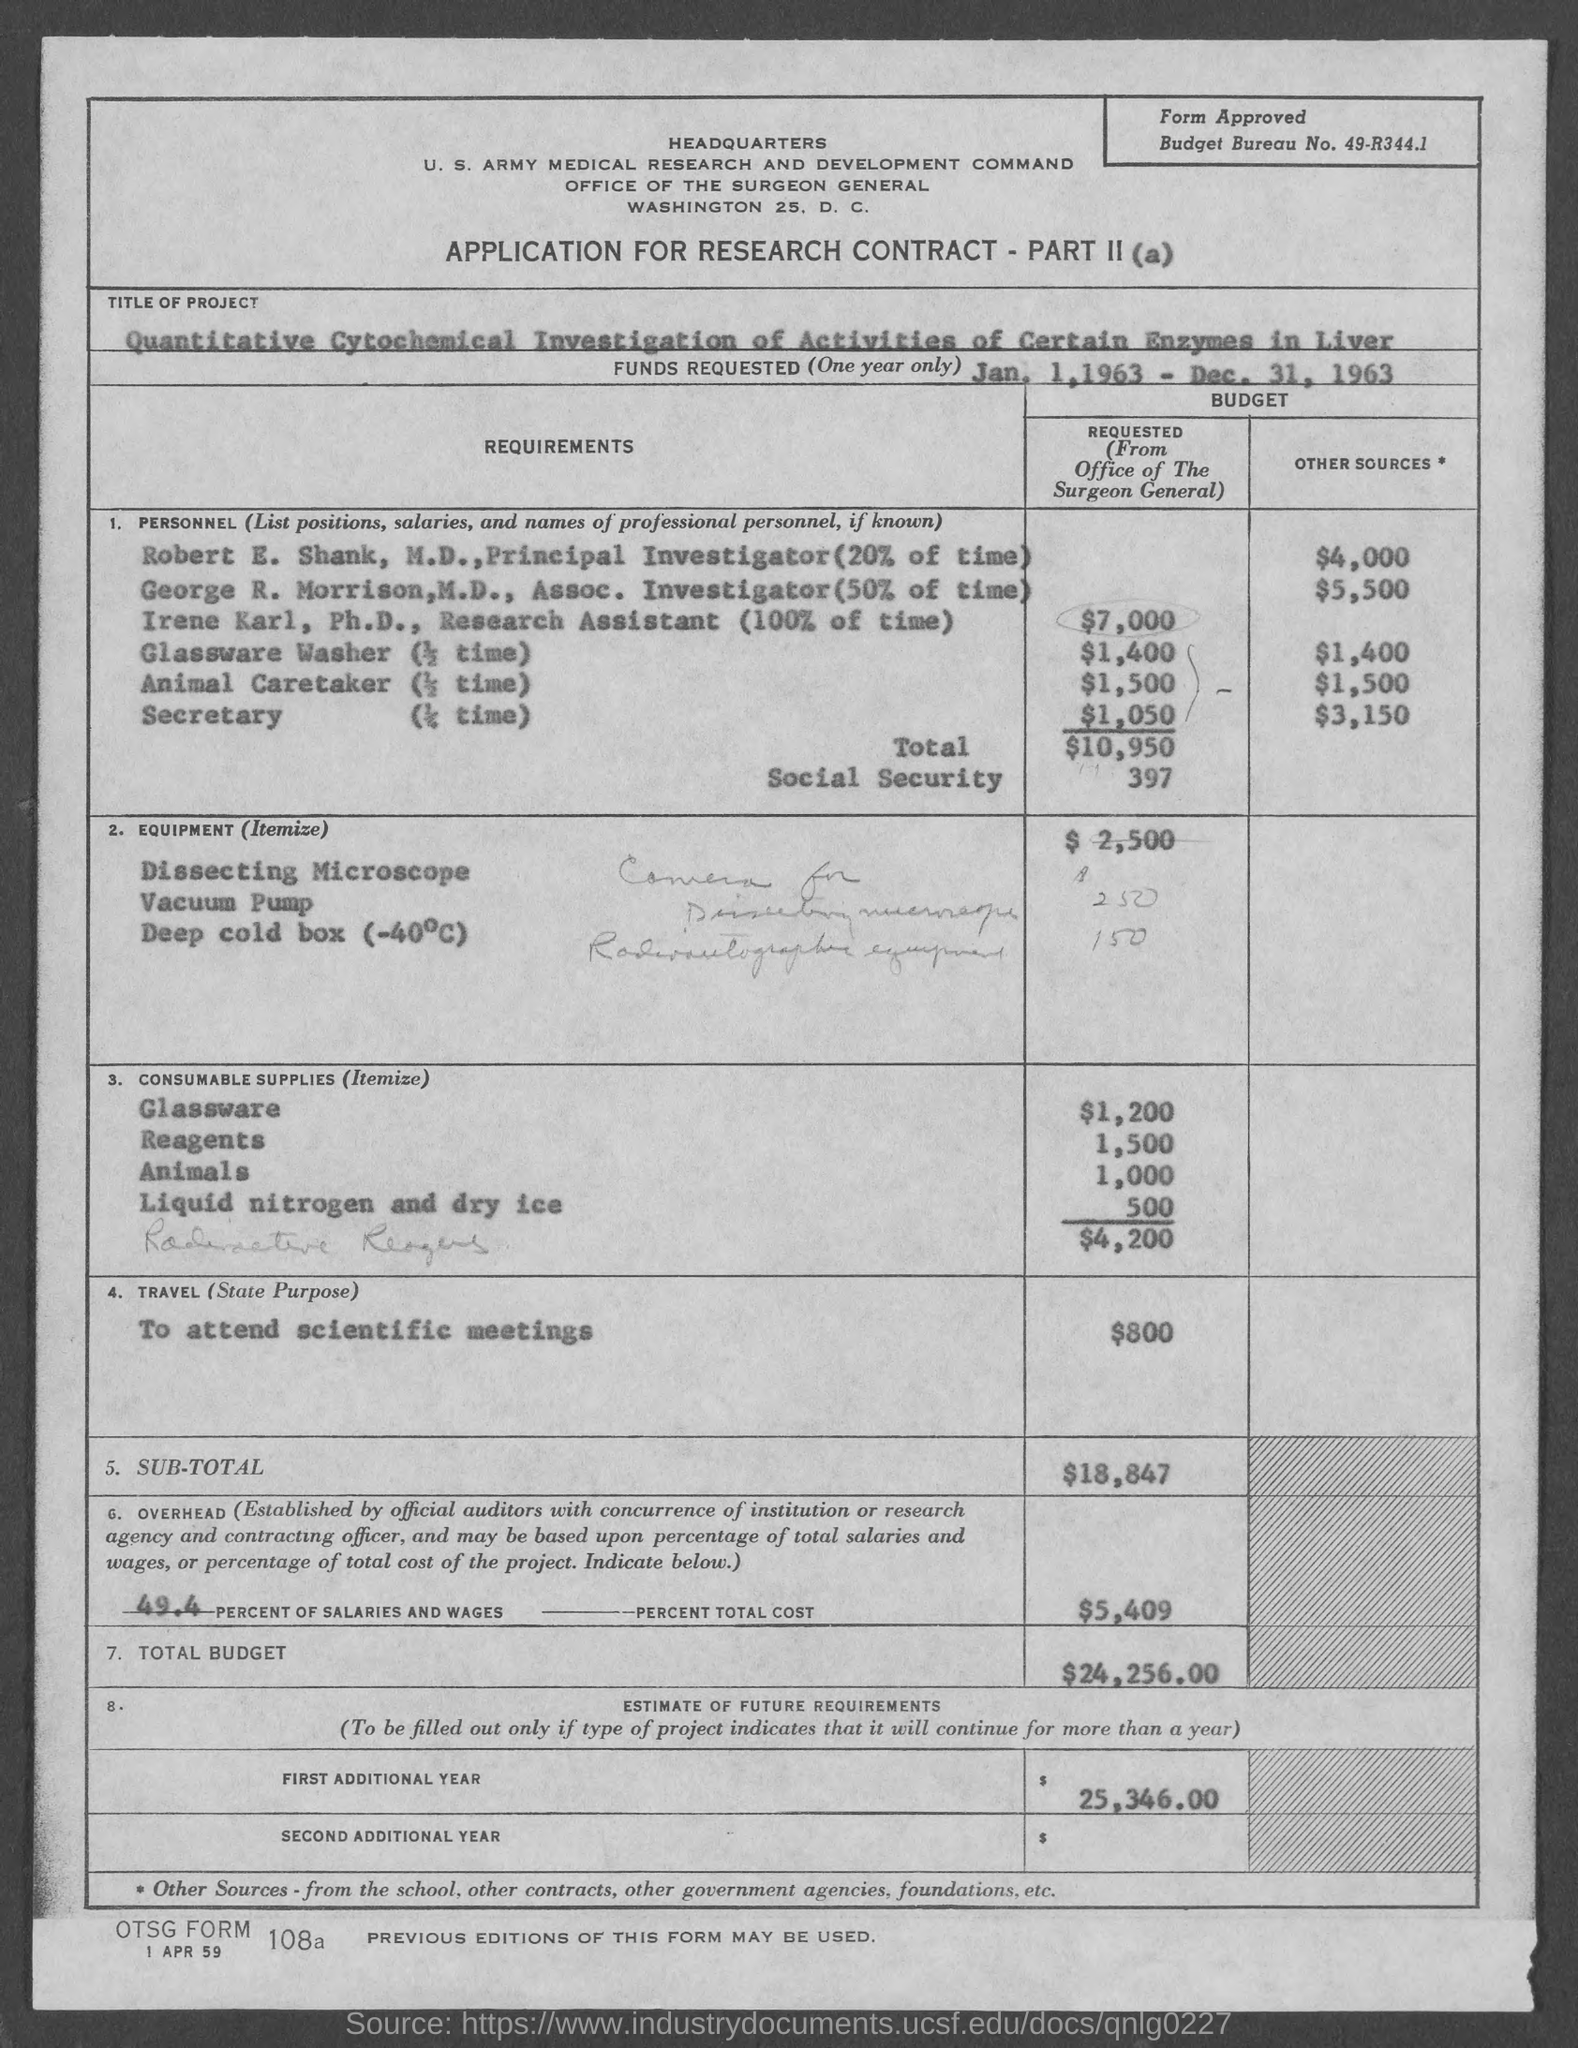Indicate a few pertinent items in this graphic. The budget bureau number is 49-R344.1. 